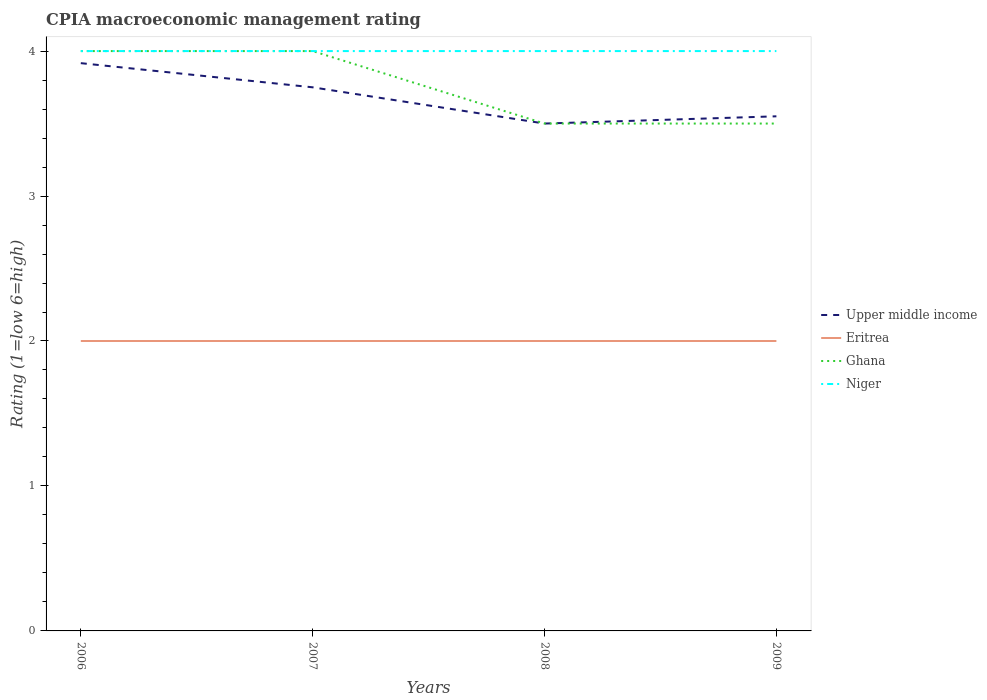How many different coloured lines are there?
Keep it short and to the point. 4. Is the number of lines equal to the number of legend labels?
Your answer should be very brief. Yes. What is the total CPIA rating in Ghana in the graph?
Your answer should be very brief. 0. What is the difference between the highest and the second highest CPIA rating in Eritrea?
Keep it short and to the point. 0. Is the CPIA rating in Upper middle income strictly greater than the CPIA rating in Niger over the years?
Provide a succinct answer. Yes. Are the values on the major ticks of Y-axis written in scientific E-notation?
Offer a very short reply. No. Does the graph contain grids?
Offer a very short reply. No. Where does the legend appear in the graph?
Offer a terse response. Center right. How many legend labels are there?
Your answer should be compact. 4. How are the legend labels stacked?
Keep it short and to the point. Vertical. What is the title of the graph?
Your response must be concise. CPIA macroeconomic management rating. Does "Low & middle income" appear as one of the legend labels in the graph?
Your response must be concise. No. What is the label or title of the X-axis?
Offer a terse response. Years. What is the Rating (1=low 6=high) in Upper middle income in 2006?
Make the answer very short. 3.92. What is the Rating (1=low 6=high) of Eritrea in 2006?
Your answer should be compact. 2. What is the Rating (1=low 6=high) in Upper middle income in 2007?
Offer a terse response. 3.75. What is the Rating (1=low 6=high) in Niger in 2007?
Ensure brevity in your answer.  4. What is the Rating (1=low 6=high) in Upper middle income in 2008?
Ensure brevity in your answer.  3.5. What is the Rating (1=low 6=high) of Ghana in 2008?
Your response must be concise. 3.5. What is the Rating (1=low 6=high) in Upper middle income in 2009?
Keep it short and to the point. 3.55. What is the Rating (1=low 6=high) of Eritrea in 2009?
Provide a short and direct response. 2. Across all years, what is the maximum Rating (1=low 6=high) in Upper middle income?
Your response must be concise. 3.92. Across all years, what is the maximum Rating (1=low 6=high) of Eritrea?
Your response must be concise. 2. Across all years, what is the maximum Rating (1=low 6=high) in Ghana?
Offer a terse response. 4. Across all years, what is the maximum Rating (1=low 6=high) in Niger?
Offer a very short reply. 4. Across all years, what is the minimum Rating (1=low 6=high) in Eritrea?
Offer a very short reply. 2. Across all years, what is the minimum Rating (1=low 6=high) in Ghana?
Make the answer very short. 3.5. Across all years, what is the minimum Rating (1=low 6=high) in Niger?
Make the answer very short. 4. What is the total Rating (1=low 6=high) of Upper middle income in the graph?
Your answer should be compact. 14.72. What is the total Rating (1=low 6=high) in Eritrea in the graph?
Provide a succinct answer. 8. What is the difference between the Rating (1=low 6=high) in Upper middle income in 2006 and that in 2007?
Your response must be concise. 0.17. What is the difference between the Rating (1=low 6=high) of Eritrea in 2006 and that in 2007?
Your answer should be very brief. 0. What is the difference between the Rating (1=low 6=high) in Niger in 2006 and that in 2007?
Give a very brief answer. 0. What is the difference between the Rating (1=low 6=high) of Upper middle income in 2006 and that in 2008?
Make the answer very short. 0.42. What is the difference between the Rating (1=low 6=high) in Ghana in 2006 and that in 2008?
Offer a terse response. 0.5. What is the difference between the Rating (1=low 6=high) of Niger in 2006 and that in 2008?
Provide a succinct answer. 0. What is the difference between the Rating (1=low 6=high) in Upper middle income in 2006 and that in 2009?
Your answer should be very brief. 0.37. What is the difference between the Rating (1=low 6=high) of Eritrea in 2006 and that in 2009?
Make the answer very short. 0. What is the difference between the Rating (1=low 6=high) of Upper middle income in 2007 and that in 2008?
Keep it short and to the point. 0.25. What is the difference between the Rating (1=low 6=high) in Ghana in 2007 and that in 2008?
Give a very brief answer. 0.5. What is the difference between the Rating (1=low 6=high) of Niger in 2007 and that in 2008?
Keep it short and to the point. 0. What is the difference between the Rating (1=low 6=high) of Upper middle income in 2007 and that in 2009?
Your answer should be compact. 0.2. What is the difference between the Rating (1=low 6=high) in Eritrea in 2007 and that in 2009?
Your answer should be very brief. 0. What is the difference between the Rating (1=low 6=high) of Upper middle income in 2008 and that in 2009?
Your answer should be very brief. -0.05. What is the difference between the Rating (1=low 6=high) in Eritrea in 2008 and that in 2009?
Offer a very short reply. 0. What is the difference between the Rating (1=low 6=high) of Niger in 2008 and that in 2009?
Offer a very short reply. 0. What is the difference between the Rating (1=low 6=high) of Upper middle income in 2006 and the Rating (1=low 6=high) of Eritrea in 2007?
Your answer should be very brief. 1.92. What is the difference between the Rating (1=low 6=high) of Upper middle income in 2006 and the Rating (1=low 6=high) of Ghana in 2007?
Offer a very short reply. -0.08. What is the difference between the Rating (1=low 6=high) of Upper middle income in 2006 and the Rating (1=low 6=high) of Niger in 2007?
Give a very brief answer. -0.08. What is the difference between the Rating (1=low 6=high) in Eritrea in 2006 and the Rating (1=low 6=high) in Niger in 2007?
Offer a terse response. -2. What is the difference between the Rating (1=low 6=high) of Upper middle income in 2006 and the Rating (1=low 6=high) of Eritrea in 2008?
Keep it short and to the point. 1.92. What is the difference between the Rating (1=low 6=high) of Upper middle income in 2006 and the Rating (1=low 6=high) of Ghana in 2008?
Your response must be concise. 0.42. What is the difference between the Rating (1=low 6=high) in Upper middle income in 2006 and the Rating (1=low 6=high) in Niger in 2008?
Provide a succinct answer. -0.08. What is the difference between the Rating (1=low 6=high) in Eritrea in 2006 and the Rating (1=low 6=high) in Ghana in 2008?
Your answer should be compact. -1.5. What is the difference between the Rating (1=low 6=high) of Upper middle income in 2006 and the Rating (1=low 6=high) of Eritrea in 2009?
Keep it short and to the point. 1.92. What is the difference between the Rating (1=low 6=high) in Upper middle income in 2006 and the Rating (1=low 6=high) in Ghana in 2009?
Your answer should be compact. 0.42. What is the difference between the Rating (1=low 6=high) of Upper middle income in 2006 and the Rating (1=low 6=high) of Niger in 2009?
Provide a succinct answer. -0.08. What is the difference between the Rating (1=low 6=high) in Eritrea in 2006 and the Rating (1=low 6=high) in Ghana in 2009?
Provide a short and direct response. -1.5. What is the difference between the Rating (1=low 6=high) in Ghana in 2006 and the Rating (1=low 6=high) in Niger in 2009?
Your answer should be very brief. 0. What is the difference between the Rating (1=low 6=high) of Eritrea in 2007 and the Rating (1=low 6=high) of Ghana in 2008?
Offer a terse response. -1.5. What is the difference between the Rating (1=low 6=high) in Eritrea in 2007 and the Rating (1=low 6=high) in Niger in 2008?
Provide a short and direct response. -2. What is the difference between the Rating (1=low 6=high) of Ghana in 2007 and the Rating (1=low 6=high) of Niger in 2008?
Your answer should be very brief. 0. What is the difference between the Rating (1=low 6=high) of Upper middle income in 2007 and the Rating (1=low 6=high) of Ghana in 2009?
Make the answer very short. 0.25. What is the difference between the Rating (1=low 6=high) of Upper middle income in 2008 and the Rating (1=low 6=high) of Niger in 2009?
Offer a terse response. -0.5. What is the difference between the Rating (1=low 6=high) in Ghana in 2008 and the Rating (1=low 6=high) in Niger in 2009?
Provide a short and direct response. -0.5. What is the average Rating (1=low 6=high) of Upper middle income per year?
Make the answer very short. 3.68. What is the average Rating (1=low 6=high) in Eritrea per year?
Provide a short and direct response. 2. What is the average Rating (1=low 6=high) in Ghana per year?
Provide a short and direct response. 3.75. What is the average Rating (1=low 6=high) of Niger per year?
Make the answer very short. 4. In the year 2006, what is the difference between the Rating (1=low 6=high) of Upper middle income and Rating (1=low 6=high) of Eritrea?
Your response must be concise. 1.92. In the year 2006, what is the difference between the Rating (1=low 6=high) in Upper middle income and Rating (1=low 6=high) in Ghana?
Offer a very short reply. -0.08. In the year 2006, what is the difference between the Rating (1=low 6=high) of Upper middle income and Rating (1=low 6=high) of Niger?
Provide a short and direct response. -0.08. In the year 2006, what is the difference between the Rating (1=low 6=high) of Eritrea and Rating (1=low 6=high) of Ghana?
Provide a succinct answer. -2. In the year 2006, what is the difference between the Rating (1=low 6=high) in Eritrea and Rating (1=low 6=high) in Niger?
Provide a succinct answer. -2. In the year 2006, what is the difference between the Rating (1=low 6=high) in Ghana and Rating (1=low 6=high) in Niger?
Ensure brevity in your answer.  0. In the year 2007, what is the difference between the Rating (1=low 6=high) of Upper middle income and Rating (1=low 6=high) of Eritrea?
Offer a terse response. 1.75. In the year 2007, what is the difference between the Rating (1=low 6=high) in Upper middle income and Rating (1=low 6=high) in Ghana?
Provide a short and direct response. -0.25. In the year 2007, what is the difference between the Rating (1=low 6=high) in Upper middle income and Rating (1=low 6=high) in Niger?
Your answer should be compact. -0.25. In the year 2007, what is the difference between the Rating (1=low 6=high) in Eritrea and Rating (1=low 6=high) in Ghana?
Provide a succinct answer. -2. In the year 2007, what is the difference between the Rating (1=low 6=high) of Eritrea and Rating (1=low 6=high) of Niger?
Your answer should be very brief. -2. In the year 2008, what is the difference between the Rating (1=low 6=high) of Upper middle income and Rating (1=low 6=high) of Ghana?
Provide a short and direct response. 0. In the year 2008, what is the difference between the Rating (1=low 6=high) in Upper middle income and Rating (1=low 6=high) in Niger?
Keep it short and to the point. -0.5. In the year 2009, what is the difference between the Rating (1=low 6=high) in Upper middle income and Rating (1=low 6=high) in Eritrea?
Offer a terse response. 1.55. In the year 2009, what is the difference between the Rating (1=low 6=high) of Upper middle income and Rating (1=low 6=high) of Niger?
Provide a short and direct response. -0.45. In the year 2009, what is the difference between the Rating (1=low 6=high) of Eritrea and Rating (1=low 6=high) of Ghana?
Your answer should be compact. -1.5. In the year 2009, what is the difference between the Rating (1=low 6=high) in Eritrea and Rating (1=low 6=high) in Niger?
Your response must be concise. -2. In the year 2009, what is the difference between the Rating (1=low 6=high) in Ghana and Rating (1=low 6=high) in Niger?
Your response must be concise. -0.5. What is the ratio of the Rating (1=low 6=high) of Upper middle income in 2006 to that in 2007?
Give a very brief answer. 1.04. What is the ratio of the Rating (1=low 6=high) in Eritrea in 2006 to that in 2007?
Your answer should be very brief. 1. What is the ratio of the Rating (1=low 6=high) of Upper middle income in 2006 to that in 2008?
Provide a short and direct response. 1.12. What is the ratio of the Rating (1=low 6=high) in Eritrea in 2006 to that in 2008?
Offer a very short reply. 1. What is the ratio of the Rating (1=low 6=high) of Upper middle income in 2006 to that in 2009?
Provide a short and direct response. 1.1. What is the ratio of the Rating (1=low 6=high) in Ghana in 2006 to that in 2009?
Provide a succinct answer. 1.14. What is the ratio of the Rating (1=low 6=high) of Niger in 2006 to that in 2009?
Offer a terse response. 1. What is the ratio of the Rating (1=low 6=high) in Upper middle income in 2007 to that in 2008?
Provide a short and direct response. 1.07. What is the ratio of the Rating (1=low 6=high) of Eritrea in 2007 to that in 2008?
Provide a succinct answer. 1. What is the ratio of the Rating (1=low 6=high) in Ghana in 2007 to that in 2008?
Your answer should be very brief. 1.14. What is the ratio of the Rating (1=low 6=high) in Niger in 2007 to that in 2008?
Ensure brevity in your answer.  1. What is the ratio of the Rating (1=low 6=high) in Upper middle income in 2007 to that in 2009?
Offer a terse response. 1.06. What is the ratio of the Rating (1=low 6=high) of Eritrea in 2007 to that in 2009?
Make the answer very short. 1. What is the ratio of the Rating (1=low 6=high) of Upper middle income in 2008 to that in 2009?
Keep it short and to the point. 0.99. What is the ratio of the Rating (1=low 6=high) in Eritrea in 2008 to that in 2009?
Your answer should be very brief. 1. What is the ratio of the Rating (1=low 6=high) in Ghana in 2008 to that in 2009?
Give a very brief answer. 1. What is the difference between the highest and the second highest Rating (1=low 6=high) of Upper middle income?
Keep it short and to the point. 0.17. What is the difference between the highest and the lowest Rating (1=low 6=high) in Upper middle income?
Offer a very short reply. 0.42. What is the difference between the highest and the lowest Rating (1=low 6=high) in Niger?
Offer a very short reply. 0. 